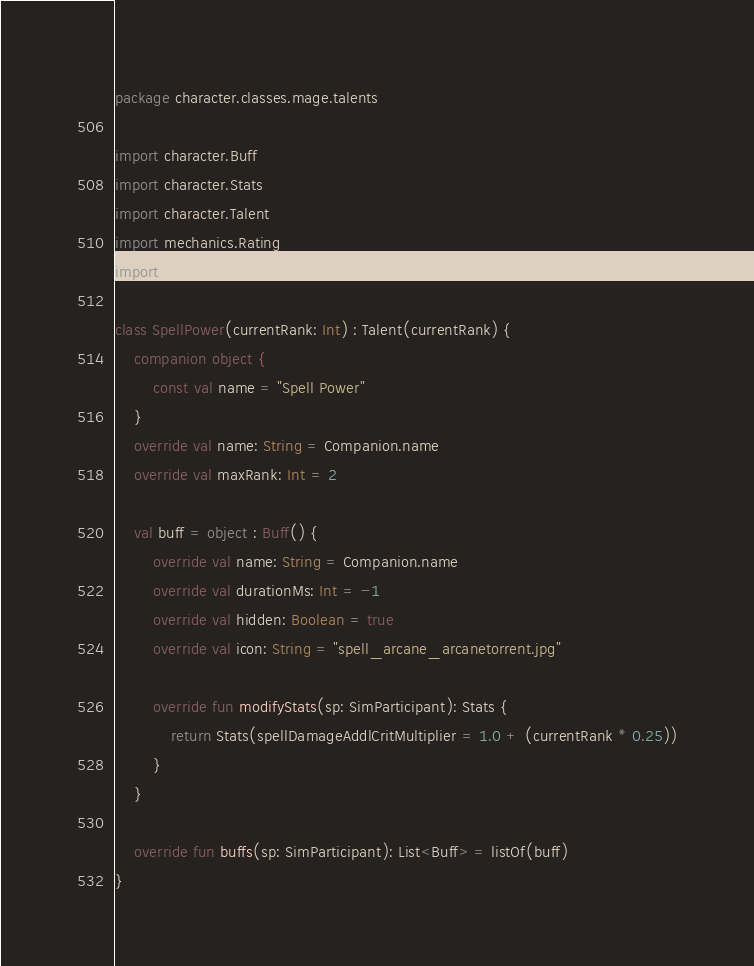Convert code to text. <code><loc_0><loc_0><loc_500><loc_500><_Kotlin_>package character.classes.mage.talents

import character.Buff
import character.Stats
import character.Talent
import mechanics.Rating
import sim.SimParticipant

class SpellPower(currentRank: Int) : Talent(currentRank) {
    companion object {
        const val name = "Spell Power"
    }
    override val name: String = Companion.name
    override val maxRank: Int = 2

    val buff = object : Buff() {
        override val name: String = Companion.name
        override val durationMs: Int = -1
        override val hidden: Boolean = true
        override val icon: String = "spell_arcane_arcanetorrent.jpg"

        override fun modifyStats(sp: SimParticipant): Stats {
            return Stats(spellDamageAddlCritMultiplier = 1.0 + (currentRank * 0.25))
        }
    }

    override fun buffs(sp: SimParticipant): List<Buff> = listOf(buff)
}
</code> 